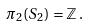<formula> <loc_0><loc_0><loc_500><loc_500>\pi _ { 2 } ( S _ { 2 } ) = \mathbb { Z } \, .</formula> 